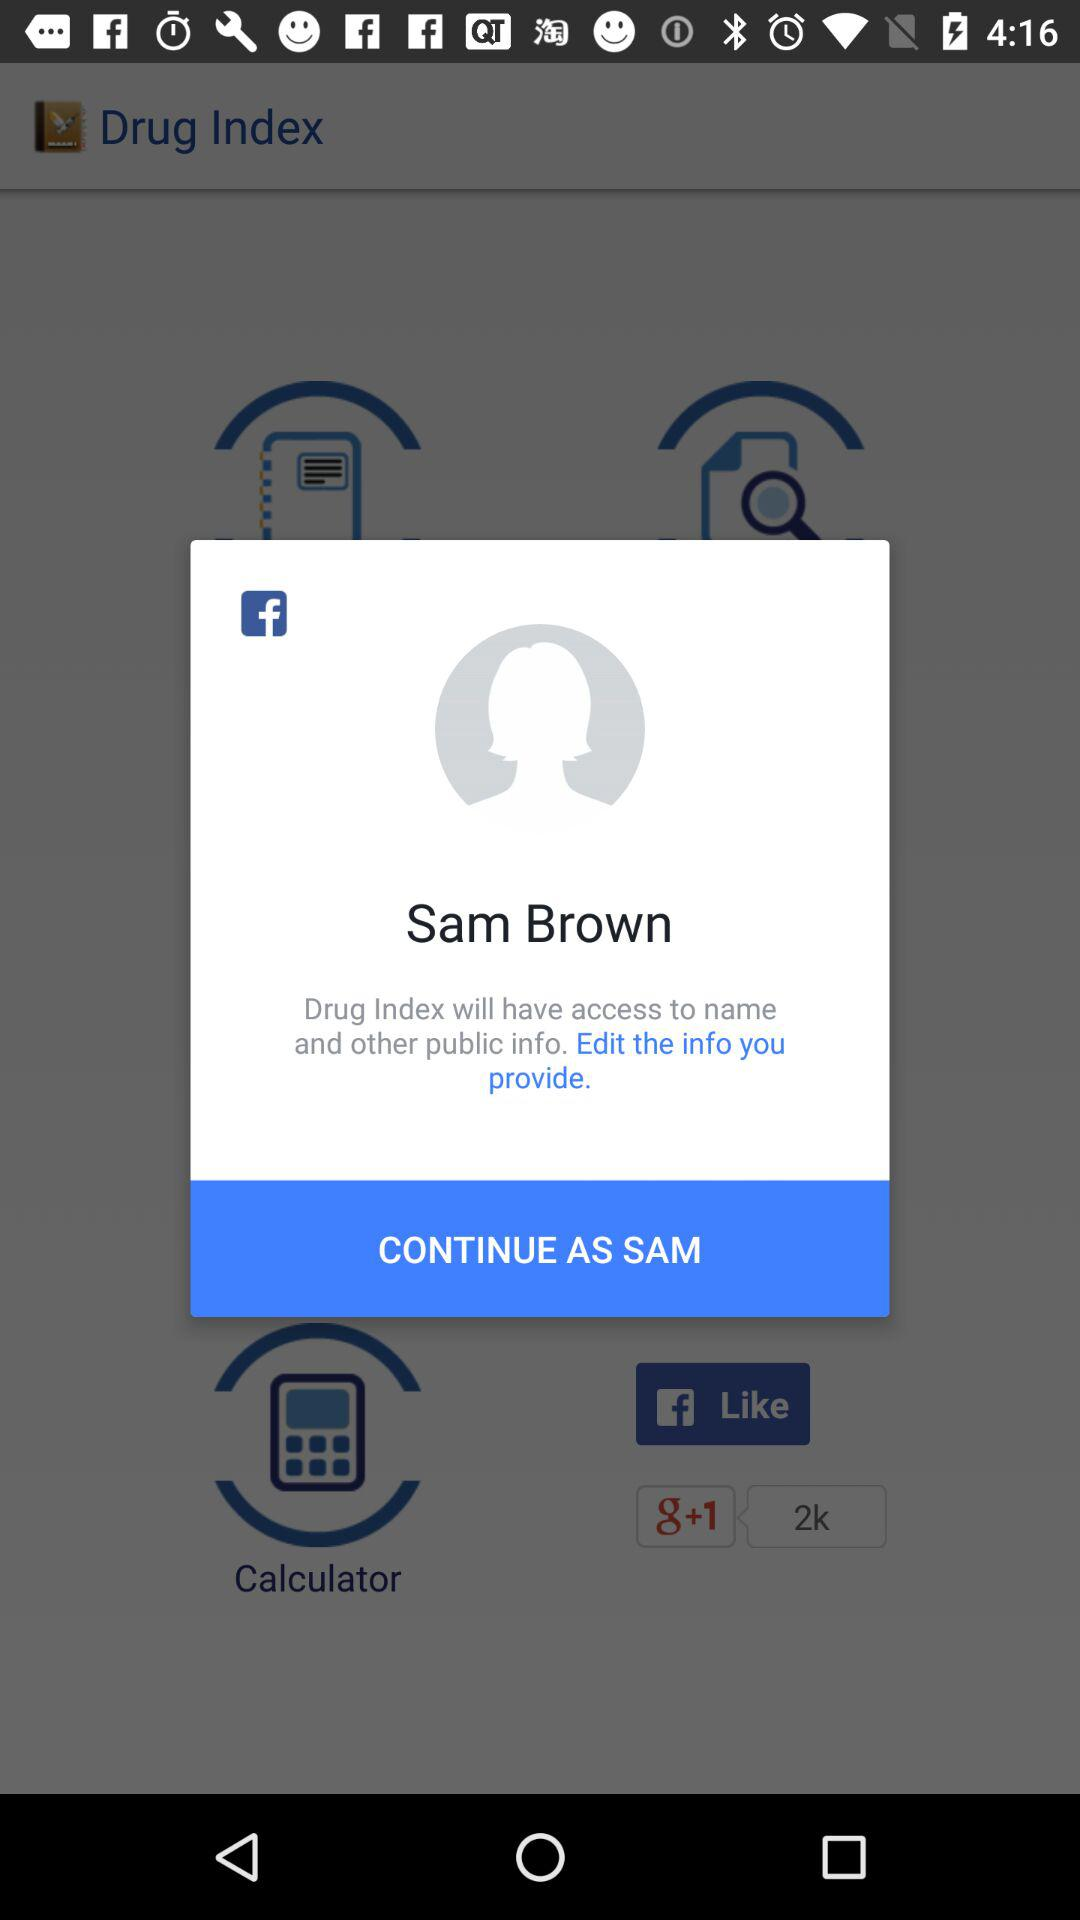What is the application name? The application name is "Drug Index". 